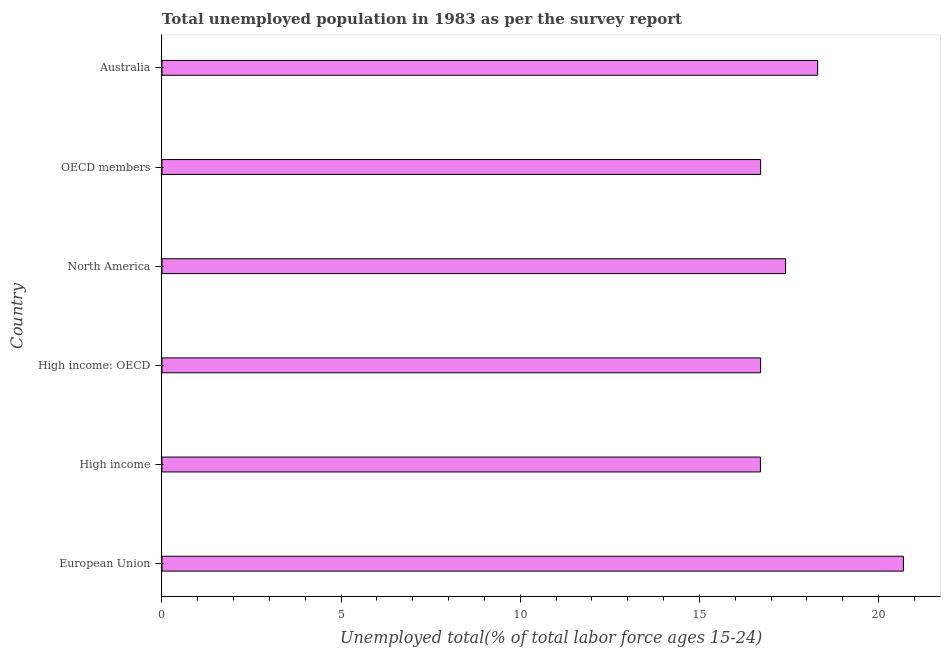What is the title of the graph?
Your answer should be very brief. Total unemployed population in 1983 as per the survey report. What is the label or title of the X-axis?
Your answer should be very brief. Unemployed total(% of total labor force ages 15-24). What is the unemployed youth in Australia?
Your answer should be very brief. 18.3. Across all countries, what is the maximum unemployed youth?
Your response must be concise. 20.69. Across all countries, what is the minimum unemployed youth?
Provide a short and direct response. 16.7. In which country was the unemployed youth maximum?
Ensure brevity in your answer.  European Union. In which country was the unemployed youth minimum?
Offer a very short reply. High income. What is the sum of the unemployed youth?
Provide a short and direct response. 106.52. What is the difference between the unemployed youth in High income: OECD and OECD members?
Give a very brief answer. 0. What is the average unemployed youth per country?
Make the answer very short. 17.75. What is the median unemployed youth?
Make the answer very short. 17.06. What is the ratio of the unemployed youth in European Union to that in North America?
Your answer should be compact. 1.19. Is the difference between the unemployed youth in Australia and High income: OECD greater than the difference between any two countries?
Give a very brief answer. No. What is the difference between the highest and the second highest unemployed youth?
Your response must be concise. 2.4. What is the difference between the highest and the lowest unemployed youth?
Your answer should be very brief. 3.99. How many bars are there?
Your response must be concise. 6. How many countries are there in the graph?
Provide a short and direct response. 6. What is the Unemployed total(% of total labor force ages 15-24) of European Union?
Make the answer very short. 20.69. What is the Unemployed total(% of total labor force ages 15-24) of High income?
Your response must be concise. 16.7. What is the Unemployed total(% of total labor force ages 15-24) in High income: OECD?
Your answer should be very brief. 16.71. What is the Unemployed total(% of total labor force ages 15-24) of North America?
Your answer should be compact. 17.4. What is the Unemployed total(% of total labor force ages 15-24) of OECD members?
Your answer should be very brief. 16.71. What is the Unemployed total(% of total labor force ages 15-24) in Australia?
Make the answer very short. 18.3. What is the difference between the Unemployed total(% of total labor force ages 15-24) in European Union and High income?
Make the answer very short. 3.99. What is the difference between the Unemployed total(% of total labor force ages 15-24) in European Union and High income: OECD?
Provide a succinct answer. 3.99. What is the difference between the Unemployed total(% of total labor force ages 15-24) in European Union and North America?
Your response must be concise. 3.29. What is the difference between the Unemployed total(% of total labor force ages 15-24) in European Union and OECD members?
Offer a terse response. 3.99. What is the difference between the Unemployed total(% of total labor force ages 15-24) in European Union and Australia?
Offer a very short reply. 2.39. What is the difference between the Unemployed total(% of total labor force ages 15-24) in High income and High income: OECD?
Offer a very short reply. -0.01. What is the difference between the Unemployed total(% of total labor force ages 15-24) in High income and North America?
Your answer should be compact. -0.7. What is the difference between the Unemployed total(% of total labor force ages 15-24) in High income and OECD members?
Keep it short and to the point. -0.01. What is the difference between the Unemployed total(% of total labor force ages 15-24) in High income and Australia?
Make the answer very short. -1.6. What is the difference between the Unemployed total(% of total labor force ages 15-24) in High income: OECD and North America?
Your response must be concise. -0.7. What is the difference between the Unemployed total(% of total labor force ages 15-24) in High income: OECD and Australia?
Offer a terse response. -1.59. What is the difference between the Unemployed total(% of total labor force ages 15-24) in North America and OECD members?
Your answer should be compact. 0.7. What is the difference between the Unemployed total(% of total labor force ages 15-24) in North America and Australia?
Keep it short and to the point. -0.9. What is the difference between the Unemployed total(% of total labor force ages 15-24) in OECD members and Australia?
Keep it short and to the point. -1.59. What is the ratio of the Unemployed total(% of total labor force ages 15-24) in European Union to that in High income?
Your answer should be compact. 1.24. What is the ratio of the Unemployed total(% of total labor force ages 15-24) in European Union to that in High income: OECD?
Ensure brevity in your answer.  1.24. What is the ratio of the Unemployed total(% of total labor force ages 15-24) in European Union to that in North America?
Ensure brevity in your answer.  1.19. What is the ratio of the Unemployed total(% of total labor force ages 15-24) in European Union to that in OECD members?
Ensure brevity in your answer.  1.24. What is the ratio of the Unemployed total(% of total labor force ages 15-24) in European Union to that in Australia?
Your answer should be very brief. 1.13. What is the ratio of the Unemployed total(% of total labor force ages 15-24) in High income to that in OECD members?
Ensure brevity in your answer.  1. What is the ratio of the Unemployed total(% of total labor force ages 15-24) in High income: OECD to that in North America?
Offer a very short reply. 0.96. What is the ratio of the Unemployed total(% of total labor force ages 15-24) in High income: OECD to that in Australia?
Your answer should be very brief. 0.91. What is the ratio of the Unemployed total(% of total labor force ages 15-24) in North America to that in OECD members?
Provide a succinct answer. 1.04. What is the ratio of the Unemployed total(% of total labor force ages 15-24) in North America to that in Australia?
Your response must be concise. 0.95. 